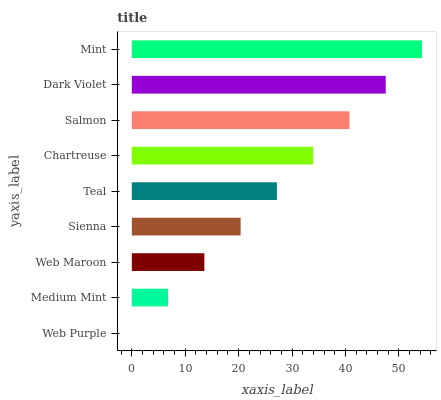Is Web Purple the minimum?
Answer yes or no. Yes. Is Mint the maximum?
Answer yes or no. Yes. Is Medium Mint the minimum?
Answer yes or no. No. Is Medium Mint the maximum?
Answer yes or no. No. Is Medium Mint greater than Web Purple?
Answer yes or no. Yes. Is Web Purple less than Medium Mint?
Answer yes or no. Yes. Is Web Purple greater than Medium Mint?
Answer yes or no. No. Is Medium Mint less than Web Purple?
Answer yes or no. No. Is Teal the high median?
Answer yes or no. Yes. Is Teal the low median?
Answer yes or no. Yes. Is Chartreuse the high median?
Answer yes or no. No. Is Web Purple the low median?
Answer yes or no. No. 